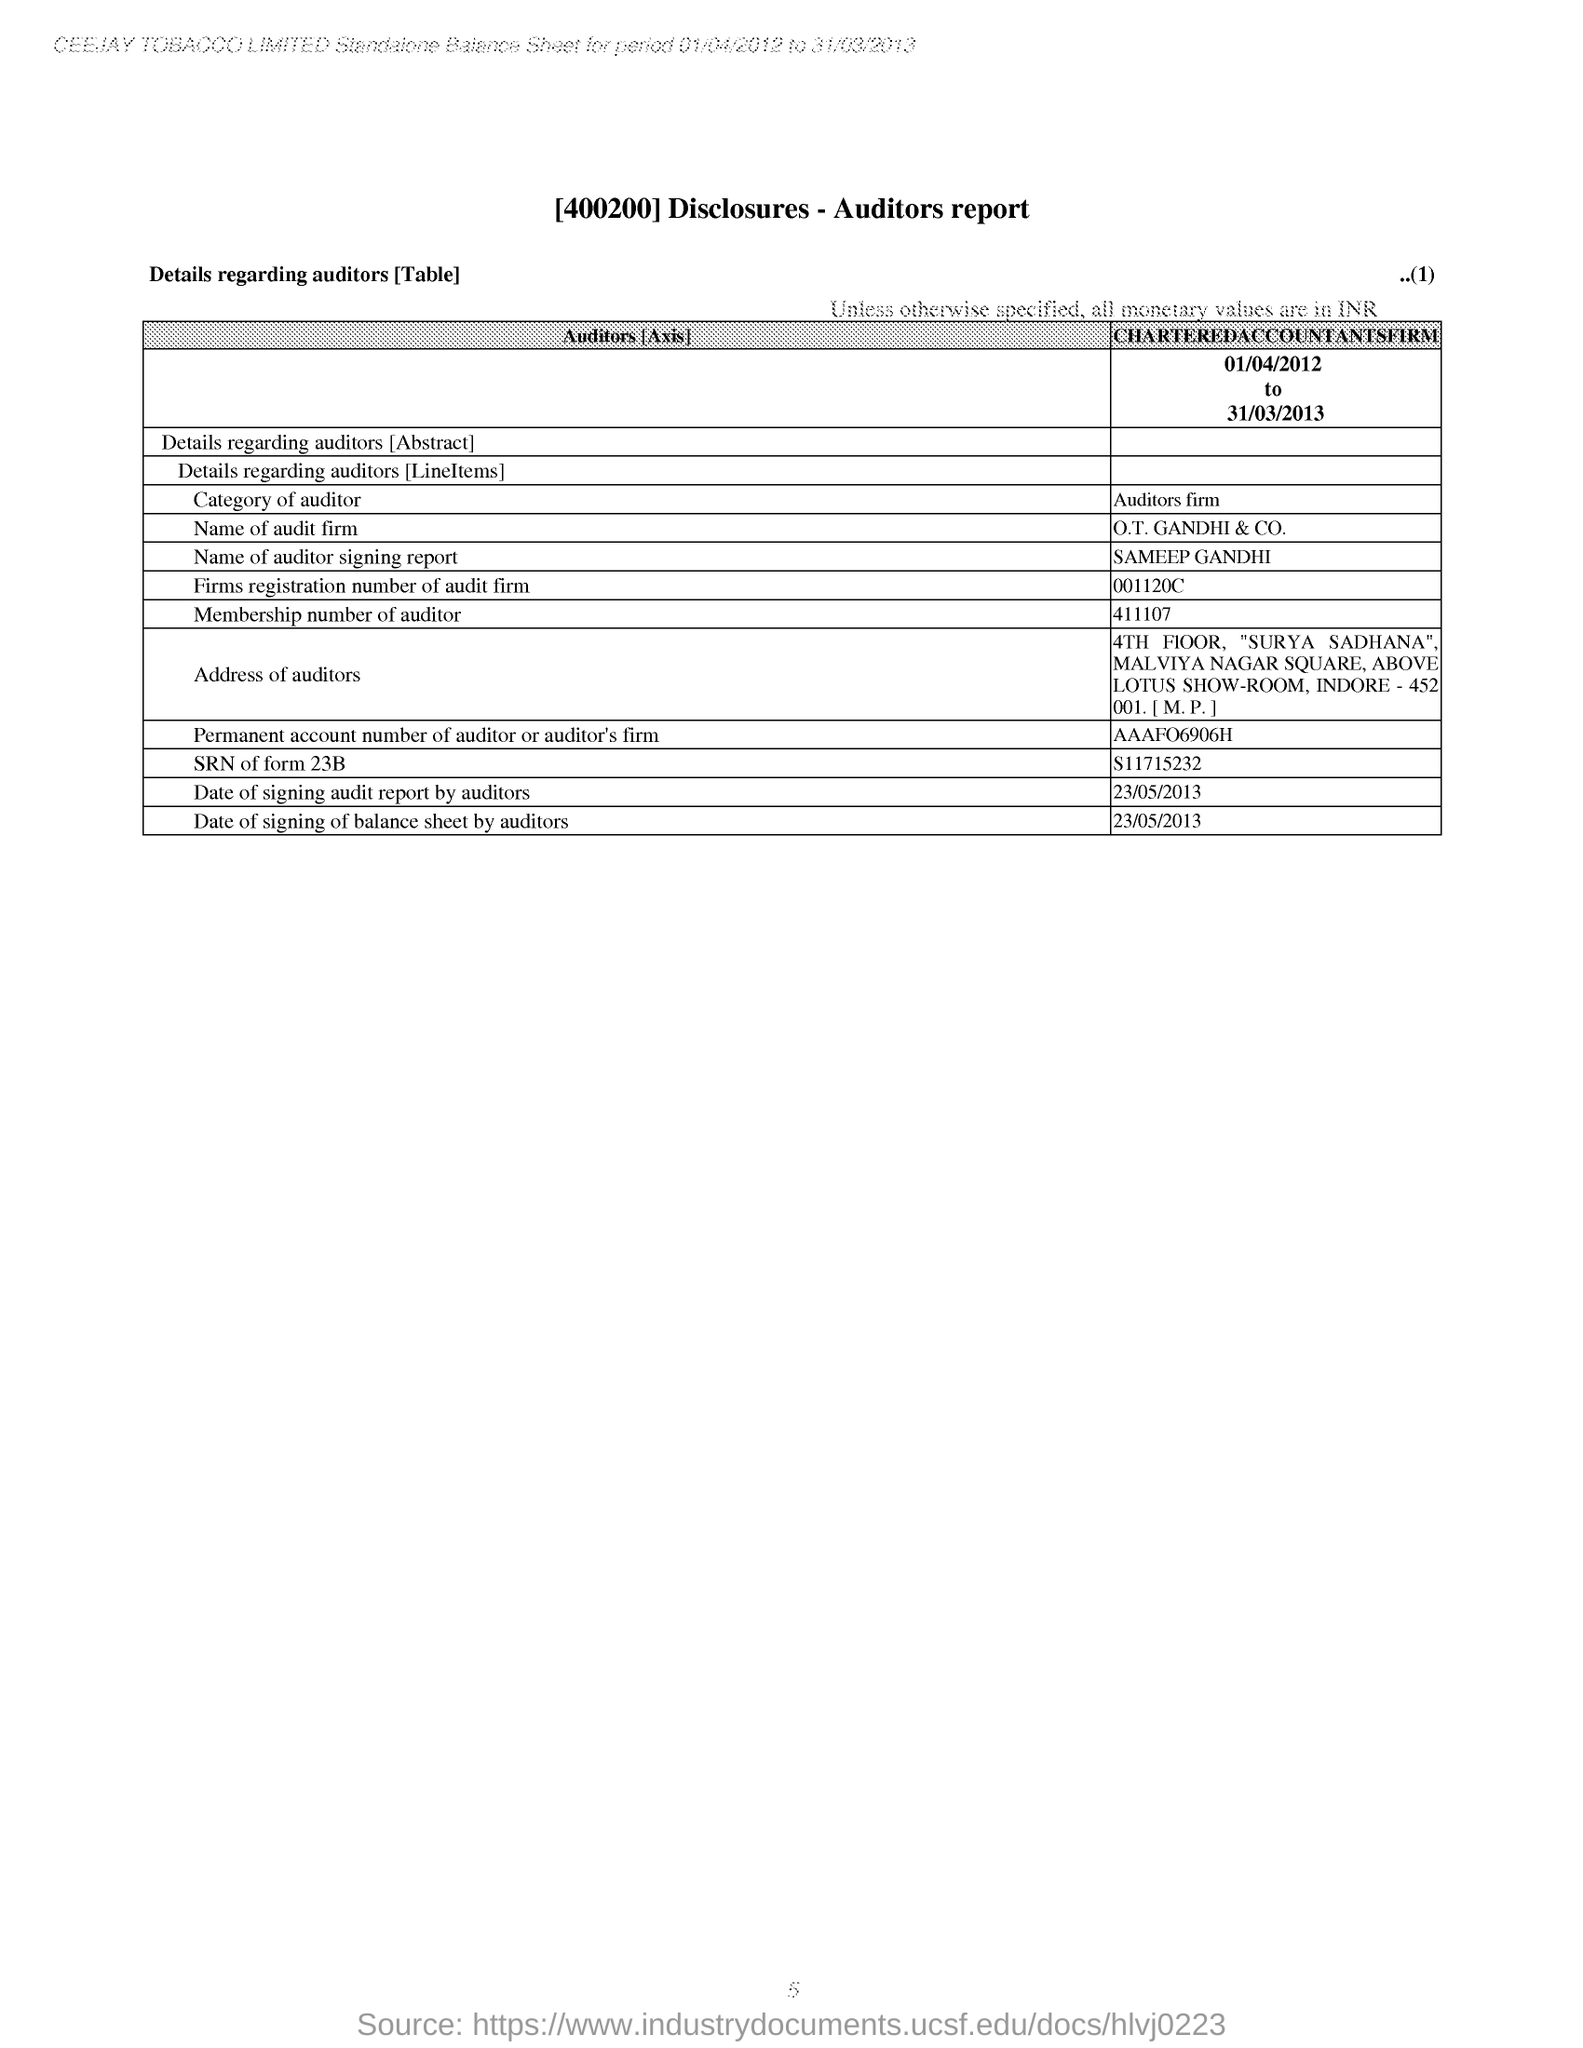What is the name of the auditor mentioned in the report?
Offer a terse response. SAMEEP GANDHI. What is the city mentioned in the address of the auditor?
Your answer should be compact. INDORE. What is the membership number of auditor mentioned in report?
Your answer should be very brief. 411107. What is the table mentiones about?
Provide a short and direct response. Details regarding auditors [Table]. 